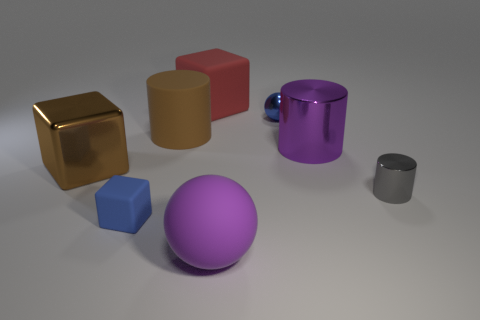Can you describe the lighting and shadows in the scene? The scene is softly lit from above, casting gentle shadows on the surface underneath each object. The lighting accentuates the shapes and textures, and the shadows are consistent, implying a single light source not visible in the image. 